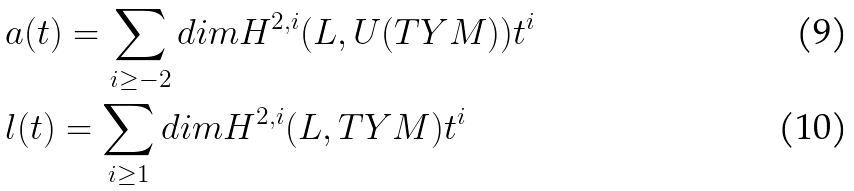Convert formula to latex. <formula><loc_0><loc_0><loc_500><loc_500>& a ( t ) = \sum _ { i \geq - 2 } d i m H ^ { 2 , i } ( L , U ( T Y M ) ) t ^ { i } \\ & l ( t ) = \sum _ { i \geq 1 } d i m H ^ { 2 , i } ( L , T Y M ) t ^ { i }</formula> 